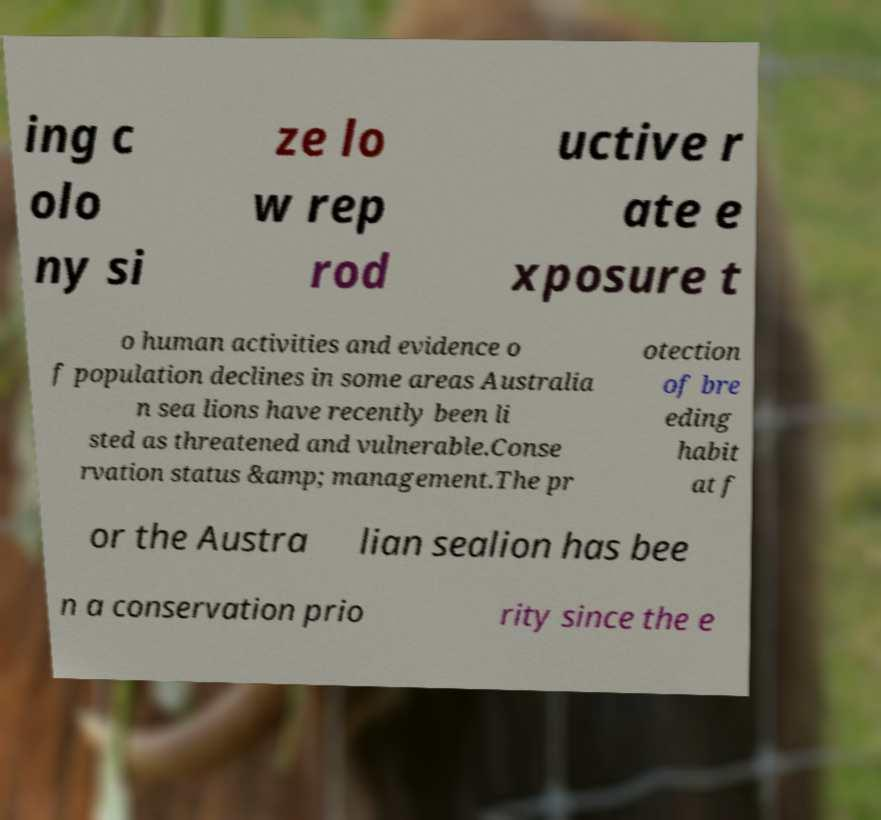I need the written content from this picture converted into text. Can you do that? ing c olo ny si ze lo w rep rod uctive r ate e xposure t o human activities and evidence o f population declines in some areas Australia n sea lions have recently been li sted as threatened and vulnerable.Conse rvation status &amp; management.The pr otection of bre eding habit at f or the Austra lian sealion has bee n a conservation prio rity since the e 